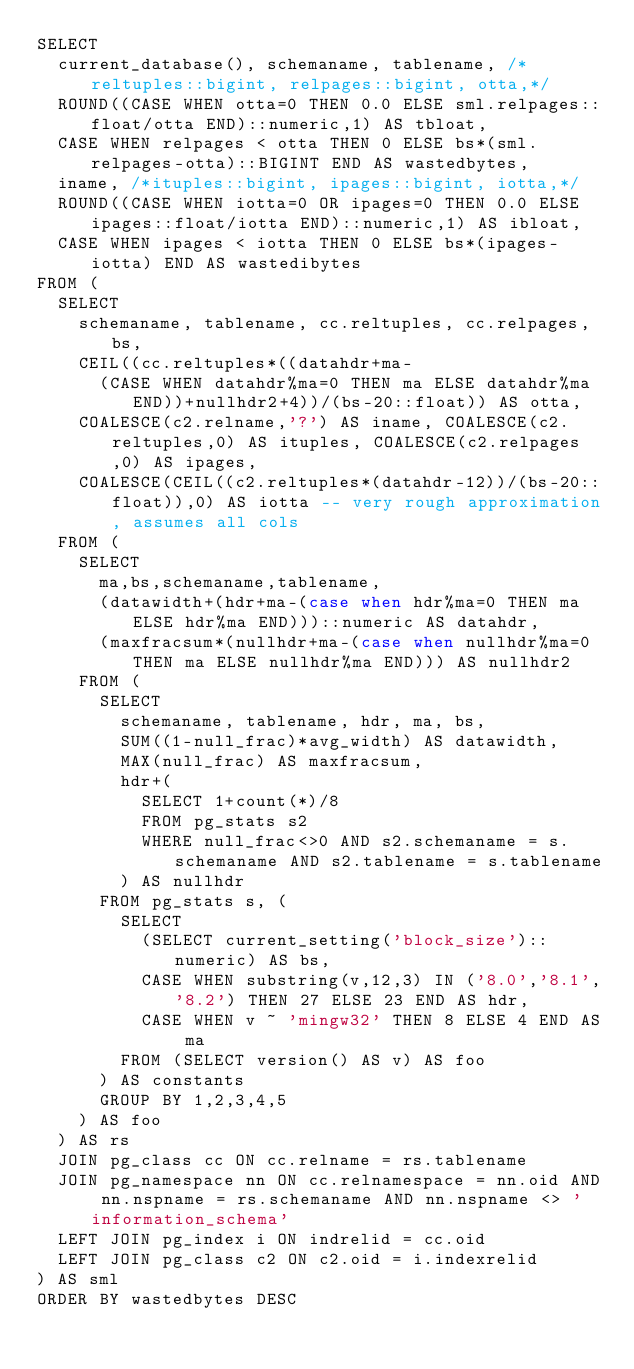Convert code to text. <code><loc_0><loc_0><loc_500><loc_500><_SQL_>SELECT
  current_database(), schemaname, tablename, /*reltuples::bigint, relpages::bigint, otta,*/
  ROUND((CASE WHEN otta=0 THEN 0.0 ELSE sml.relpages::float/otta END)::numeric,1) AS tbloat,
  CASE WHEN relpages < otta THEN 0 ELSE bs*(sml.relpages-otta)::BIGINT END AS wastedbytes,
  iname, /*ituples::bigint, ipages::bigint, iotta,*/
  ROUND((CASE WHEN iotta=0 OR ipages=0 THEN 0.0 ELSE ipages::float/iotta END)::numeric,1) AS ibloat,
  CASE WHEN ipages < iotta THEN 0 ELSE bs*(ipages-iotta) END AS wastedibytes
FROM (
  SELECT
    schemaname, tablename, cc.reltuples, cc.relpages, bs,
    CEIL((cc.reltuples*((datahdr+ma-
      (CASE WHEN datahdr%ma=0 THEN ma ELSE datahdr%ma END))+nullhdr2+4))/(bs-20::float)) AS otta,
    COALESCE(c2.relname,'?') AS iname, COALESCE(c2.reltuples,0) AS ituples, COALESCE(c2.relpages,0) AS ipages,
    COALESCE(CEIL((c2.reltuples*(datahdr-12))/(bs-20::float)),0) AS iotta -- very rough approximation, assumes all cols
  FROM (
    SELECT
      ma,bs,schemaname,tablename,
      (datawidth+(hdr+ma-(case when hdr%ma=0 THEN ma ELSE hdr%ma END)))::numeric AS datahdr,
      (maxfracsum*(nullhdr+ma-(case when nullhdr%ma=0 THEN ma ELSE nullhdr%ma END))) AS nullhdr2
    FROM (
      SELECT
        schemaname, tablename, hdr, ma, bs,
        SUM((1-null_frac)*avg_width) AS datawidth,
        MAX(null_frac) AS maxfracsum,
        hdr+(
          SELECT 1+count(*)/8
          FROM pg_stats s2
          WHERE null_frac<>0 AND s2.schemaname = s.schemaname AND s2.tablename = s.tablename
        ) AS nullhdr
      FROM pg_stats s, (
        SELECT
          (SELECT current_setting('block_size')::numeric) AS bs,
          CASE WHEN substring(v,12,3) IN ('8.0','8.1','8.2') THEN 27 ELSE 23 END AS hdr,
          CASE WHEN v ~ 'mingw32' THEN 8 ELSE 4 END AS ma
        FROM (SELECT version() AS v) AS foo
      ) AS constants
      GROUP BY 1,2,3,4,5
    ) AS foo
  ) AS rs
  JOIN pg_class cc ON cc.relname = rs.tablename
  JOIN pg_namespace nn ON cc.relnamespace = nn.oid AND nn.nspname = rs.schemaname AND nn.nspname <> 'information_schema'
  LEFT JOIN pg_index i ON indrelid = cc.oid
  LEFT JOIN pg_class c2 ON c2.oid = i.indexrelid
) AS sml
ORDER BY wastedbytes DESC</code> 